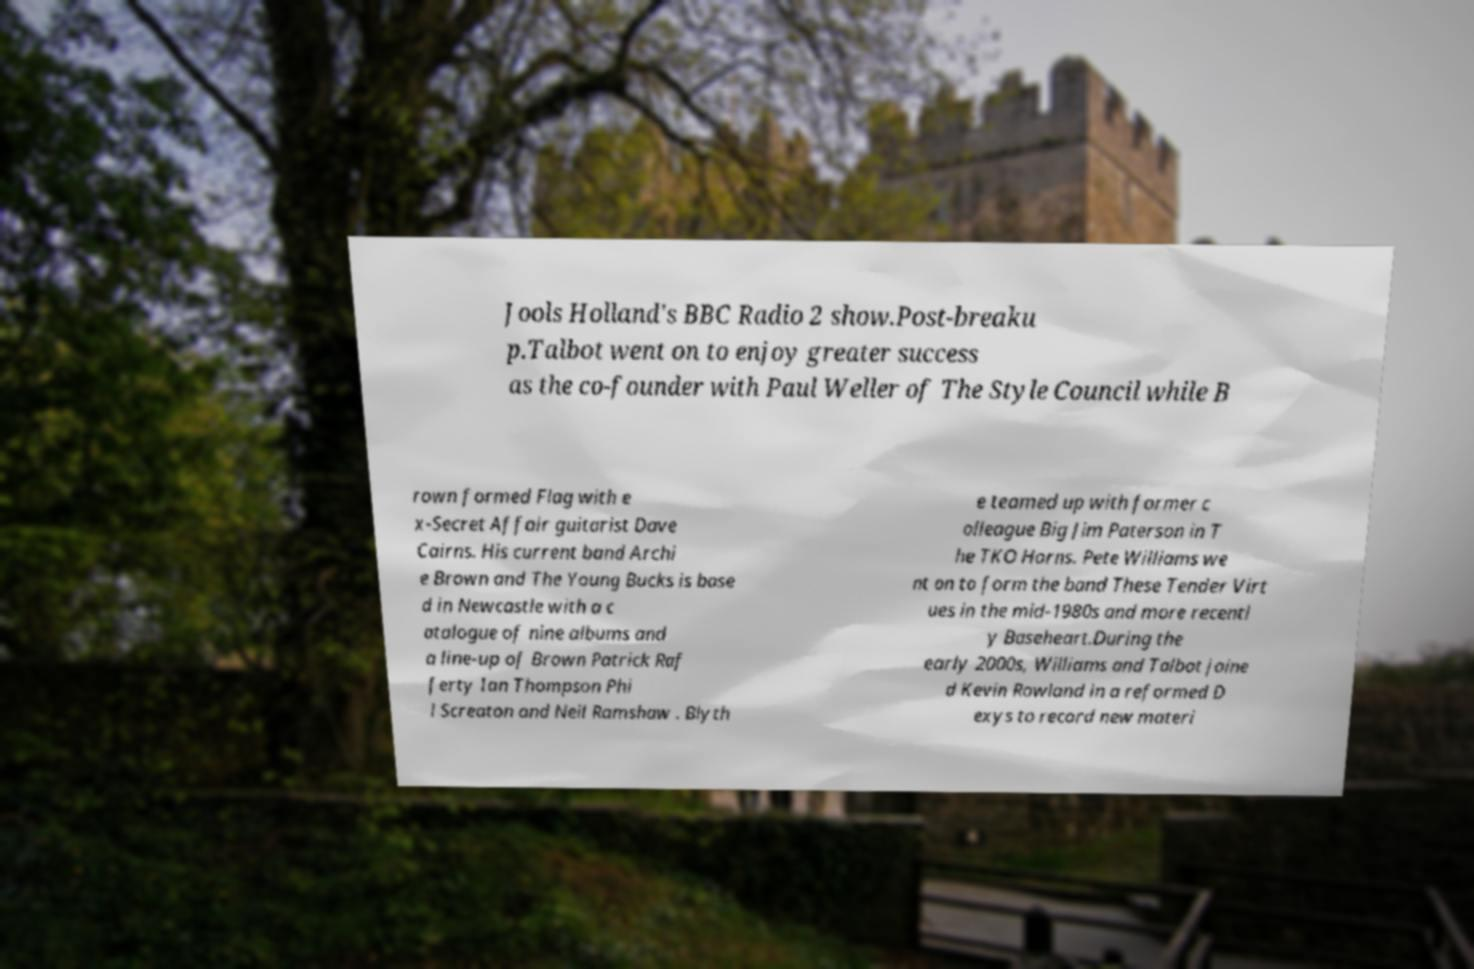Can you accurately transcribe the text from the provided image for me? Jools Holland's BBC Radio 2 show.Post-breaku p.Talbot went on to enjoy greater success as the co-founder with Paul Weller of The Style Council while B rown formed Flag with e x-Secret Affair guitarist Dave Cairns. His current band Archi e Brown and The Young Bucks is base d in Newcastle with a c atalogue of nine albums and a line-up of Brown Patrick Raf ferty Ian Thompson Phi l Screaton and Neil Ramshaw . Blyth e teamed up with former c olleague Big Jim Paterson in T he TKO Horns. Pete Williams we nt on to form the band These Tender Virt ues in the mid-1980s and more recentl y Baseheart.During the early 2000s, Williams and Talbot joine d Kevin Rowland in a reformed D exys to record new materi 